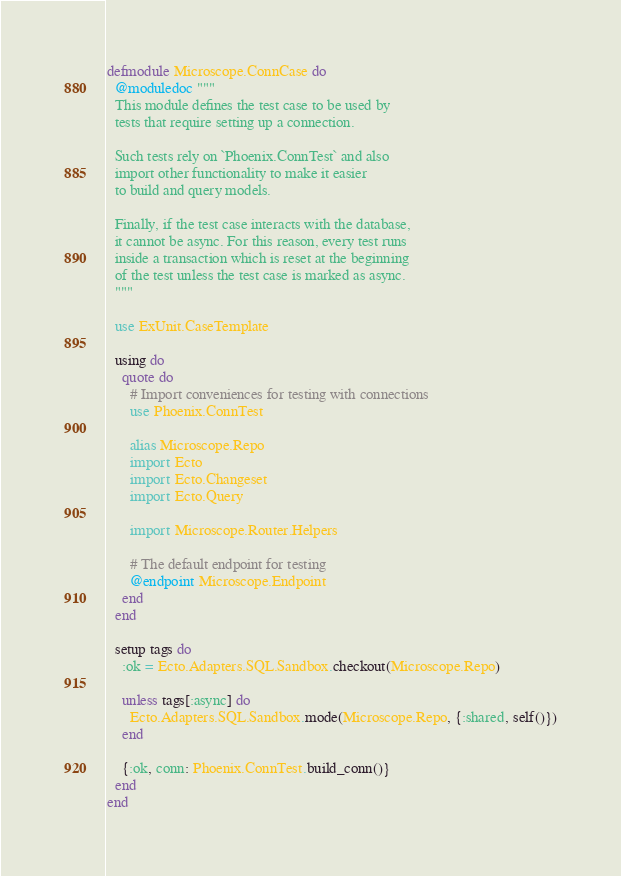Convert code to text. <code><loc_0><loc_0><loc_500><loc_500><_Elixir_>defmodule Microscope.ConnCase do
  @moduledoc """
  This module defines the test case to be used by
  tests that require setting up a connection.

  Such tests rely on `Phoenix.ConnTest` and also
  import other functionality to make it easier
  to build and query models.

  Finally, if the test case interacts with the database,
  it cannot be async. For this reason, every test runs
  inside a transaction which is reset at the beginning
  of the test unless the test case is marked as async.
  """

  use ExUnit.CaseTemplate

  using do
    quote do
      # Import conveniences for testing with connections
      use Phoenix.ConnTest

      alias Microscope.Repo
      import Ecto
      import Ecto.Changeset
      import Ecto.Query

      import Microscope.Router.Helpers

      # The default endpoint for testing
      @endpoint Microscope.Endpoint
    end
  end

  setup tags do
    :ok = Ecto.Adapters.SQL.Sandbox.checkout(Microscope.Repo)

    unless tags[:async] do
      Ecto.Adapters.SQL.Sandbox.mode(Microscope.Repo, {:shared, self()})
    end

    {:ok, conn: Phoenix.ConnTest.build_conn()}
  end
end
</code> 